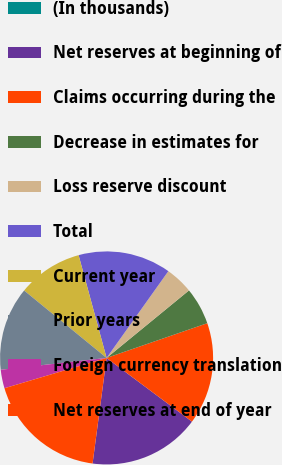Convert chart. <chart><loc_0><loc_0><loc_500><loc_500><pie_chart><fcel>(In thousands)<fcel>Net reserves at beginning of<fcel>Claims occurring during the<fcel>Decrease in estimates for<fcel>Loss reserve discount<fcel>Total<fcel>Current year<fcel>Prior years<fcel>Foreign currency translation<fcel>Net reserves at end of year<nl><fcel>0.0%<fcel>16.9%<fcel>15.49%<fcel>5.64%<fcel>4.23%<fcel>14.08%<fcel>9.86%<fcel>12.68%<fcel>2.82%<fcel>18.31%<nl></chart> 